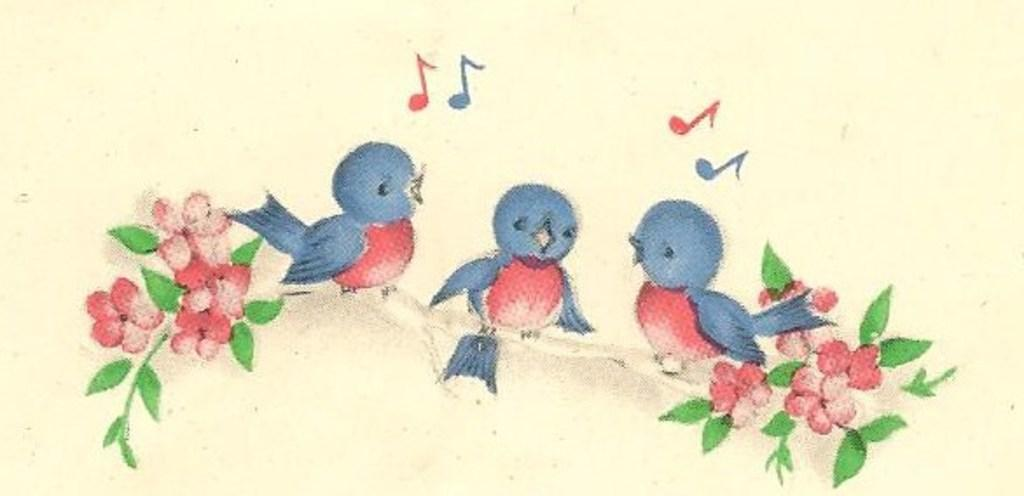What is the main subject of the image? The image contains a painting. What can be seen in the painting? There are three birds on a branch in the painting. What is attached to the branch in the painting? The branch has flowers and leaves. What is located at the top of the image? There are music symbols at the top of the image. What type of thrill can be experienced by the birds in the image? There is no indication of any thrill experienced by the birds in the image; they are simply perched on a branch. What need do the birds have in the image? The image does not provide any information about the birds' needs or desires. 